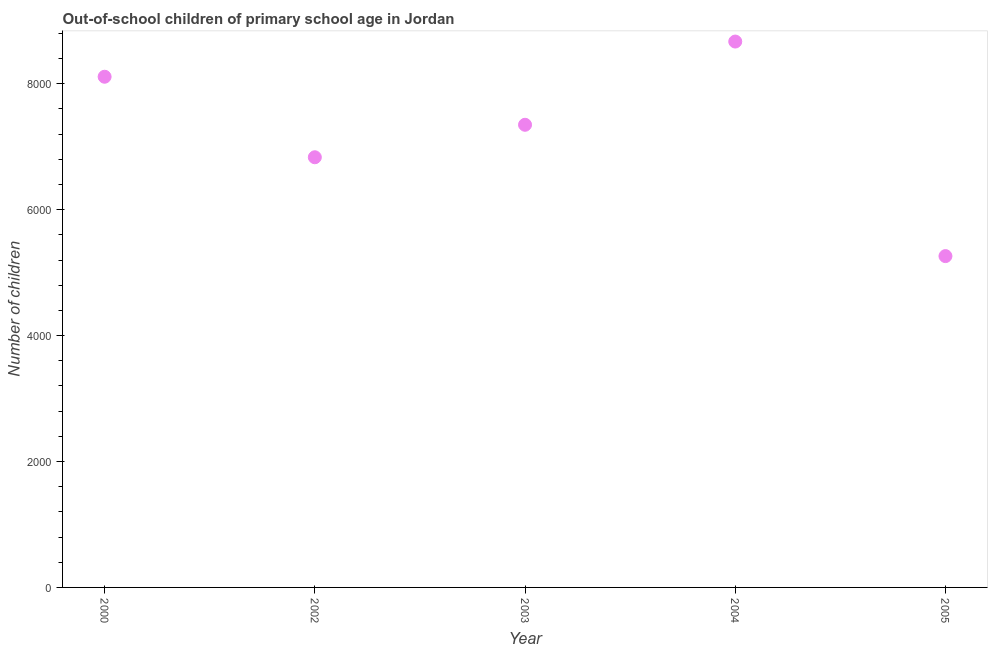What is the number of out-of-school children in 2004?
Provide a short and direct response. 8671. Across all years, what is the maximum number of out-of-school children?
Make the answer very short. 8671. Across all years, what is the minimum number of out-of-school children?
Offer a very short reply. 5263. In which year was the number of out-of-school children minimum?
Your response must be concise. 2005. What is the sum of the number of out-of-school children?
Provide a succinct answer. 3.62e+04. What is the difference between the number of out-of-school children in 2000 and 2005?
Ensure brevity in your answer.  2849. What is the average number of out-of-school children per year?
Your answer should be compact. 7245.6. What is the median number of out-of-school children?
Provide a succinct answer. 7349. What is the ratio of the number of out-of-school children in 2002 to that in 2005?
Your response must be concise. 1.3. Is the number of out-of-school children in 2000 less than that in 2005?
Your response must be concise. No. Is the difference between the number of out-of-school children in 2000 and 2003 greater than the difference between any two years?
Your answer should be very brief. No. What is the difference between the highest and the second highest number of out-of-school children?
Your answer should be very brief. 559. What is the difference between the highest and the lowest number of out-of-school children?
Provide a short and direct response. 3408. How many dotlines are there?
Give a very brief answer. 1. How many years are there in the graph?
Offer a terse response. 5. What is the difference between two consecutive major ticks on the Y-axis?
Offer a terse response. 2000. Are the values on the major ticks of Y-axis written in scientific E-notation?
Offer a terse response. No. Does the graph contain any zero values?
Make the answer very short. No. What is the title of the graph?
Provide a succinct answer. Out-of-school children of primary school age in Jordan. What is the label or title of the Y-axis?
Provide a short and direct response. Number of children. What is the Number of children in 2000?
Your answer should be compact. 8112. What is the Number of children in 2002?
Your answer should be compact. 6833. What is the Number of children in 2003?
Your answer should be very brief. 7349. What is the Number of children in 2004?
Your response must be concise. 8671. What is the Number of children in 2005?
Give a very brief answer. 5263. What is the difference between the Number of children in 2000 and 2002?
Keep it short and to the point. 1279. What is the difference between the Number of children in 2000 and 2003?
Provide a short and direct response. 763. What is the difference between the Number of children in 2000 and 2004?
Keep it short and to the point. -559. What is the difference between the Number of children in 2000 and 2005?
Keep it short and to the point. 2849. What is the difference between the Number of children in 2002 and 2003?
Provide a short and direct response. -516. What is the difference between the Number of children in 2002 and 2004?
Your answer should be very brief. -1838. What is the difference between the Number of children in 2002 and 2005?
Provide a succinct answer. 1570. What is the difference between the Number of children in 2003 and 2004?
Provide a succinct answer. -1322. What is the difference between the Number of children in 2003 and 2005?
Your answer should be compact. 2086. What is the difference between the Number of children in 2004 and 2005?
Ensure brevity in your answer.  3408. What is the ratio of the Number of children in 2000 to that in 2002?
Your answer should be very brief. 1.19. What is the ratio of the Number of children in 2000 to that in 2003?
Provide a succinct answer. 1.1. What is the ratio of the Number of children in 2000 to that in 2004?
Provide a short and direct response. 0.94. What is the ratio of the Number of children in 2000 to that in 2005?
Provide a succinct answer. 1.54. What is the ratio of the Number of children in 2002 to that in 2004?
Offer a very short reply. 0.79. What is the ratio of the Number of children in 2002 to that in 2005?
Keep it short and to the point. 1.3. What is the ratio of the Number of children in 2003 to that in 2004?
Make the answer very short. 0.85. What is the ratio of the Number of children in 2003 to that in 2005?
Offer a terse response. 1.4. What is the ratio of the Number of children in 2004 to that in 2005?
Ensure brevity in your answer.  1.65. 